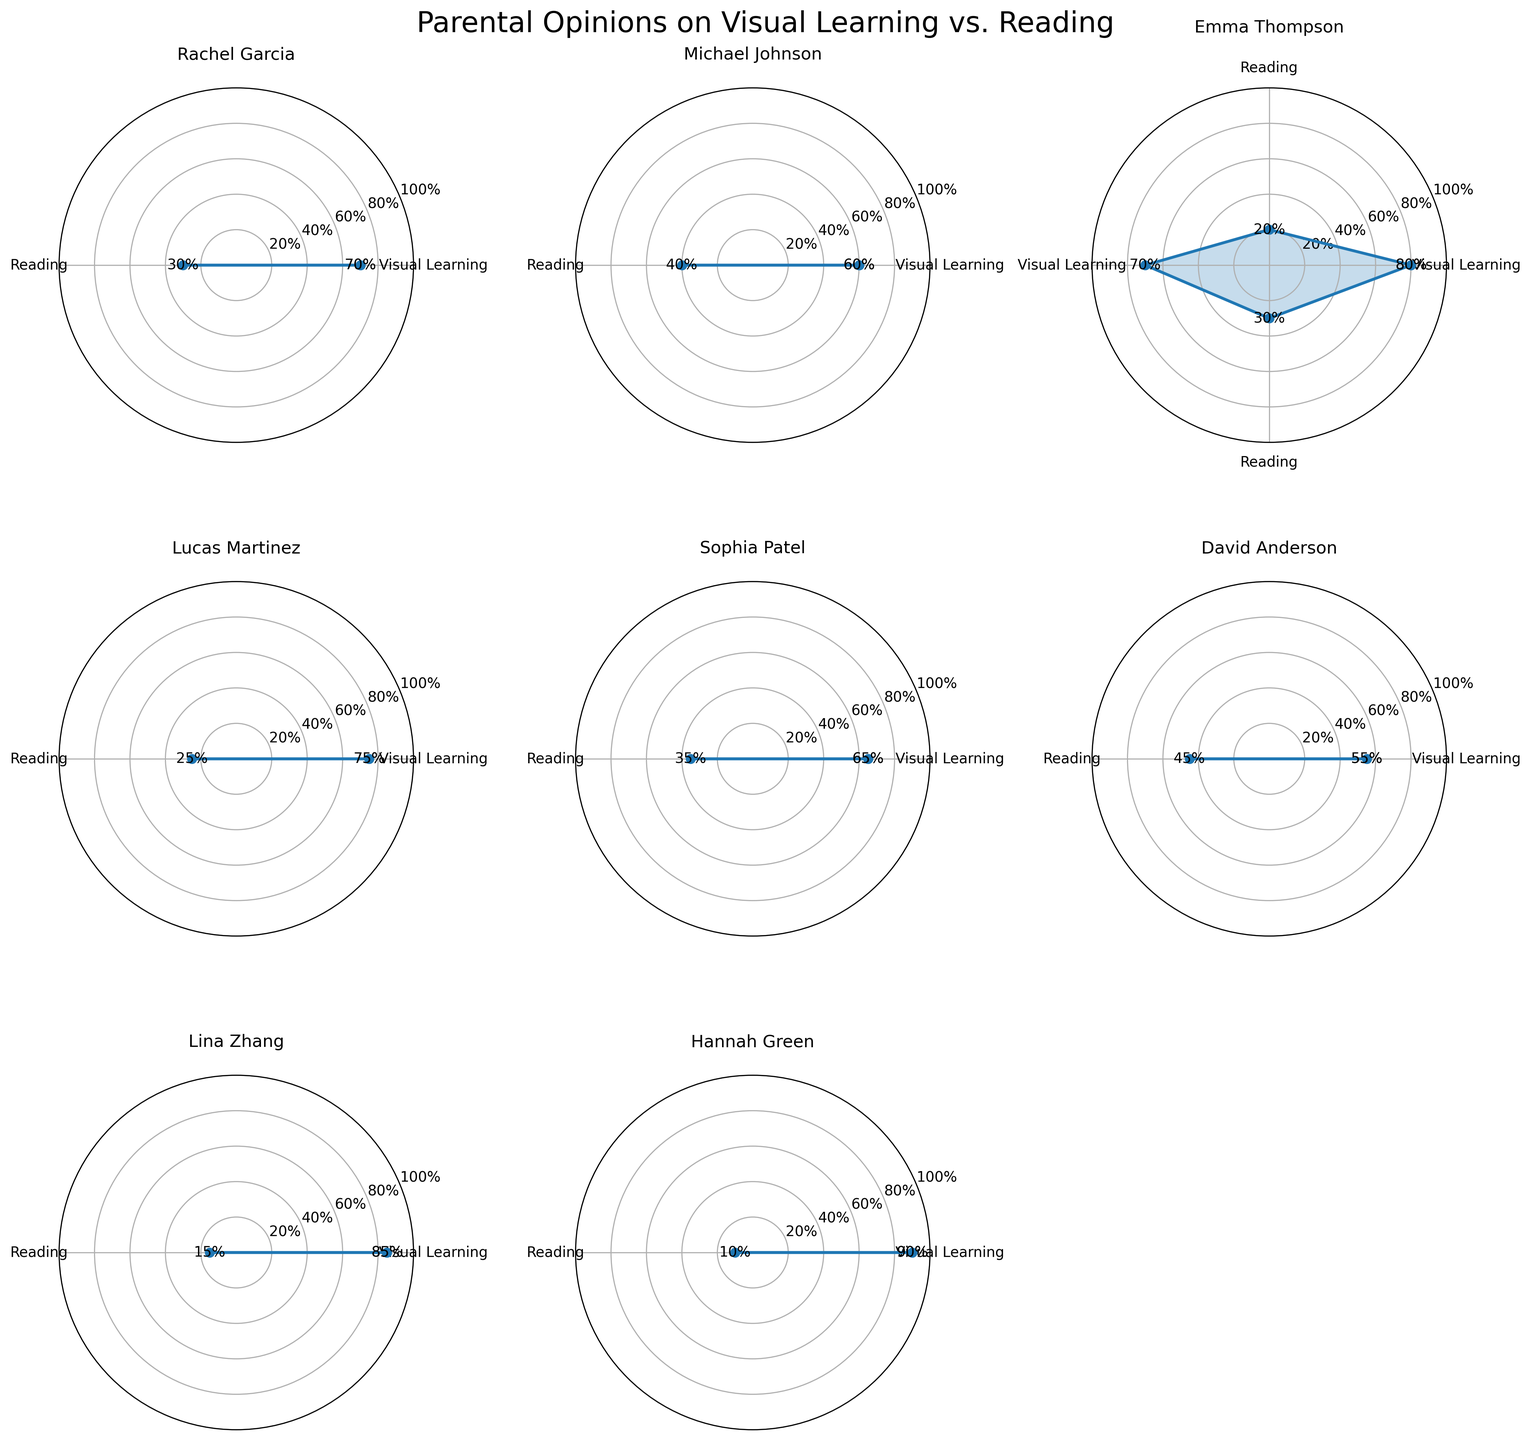What is the title of the figure? The title of the figure is usually placed at the top center and gives an overview of what the figure represents. In this case, the title reads "Parental Opinions on Visual Learning vs. Reading".
Answer: Parental Opinions on Visual Learning vs. Reading Which parent indicated the highest percentage in favor of visual learning? Look for the subplot where the percentage for "Visual Learning" is the highest. Hannah Green's subplot shows a 90% value for visual learning, which is the highest.
Answer: Hannah Green How many subplots in total are present in the figure? The total number of subplots is equivalent to the number of unique parents mentioned in the data. Count the subplots present in a 3x3 grid layout (maximum 9). Some cells might be empty, so check the number of actual subplots.
Answer: 8 Which parent has the most balanced opinion between visual learning and reading? To find the most balanced opinion, look for the subplot where the percentages for "Visual Learning" and "Reading" are the closest. For David Anderson, the values are 55% and 45%, which are the closest among all parents.
Answer: David Anderson Comparing Emma Thompson's two subplots, what is the difference in percentage for visual learning between them? Emma Thompson has two subplots. For visual learning, the values are 80% and 70%. The difference is 80% - 70% = 10%.
Answer: 10% Which parental opinion pairing shows the greatest disparity in favor of reading? To find the greatest disparity in favor of reading, identify the parent with the lowest percentage for visual learning. Lina Zhang has 85% for visual learning, implying 15% for reading, which is the smallest value for reading.
Answer: Lina Zhang What is the average percentage of parents who prefer visual learning over reading? Calculate the average percentage for visual learning by summing all the visual learning percentages and dividing by the number of parents (70 + 60 + 80 + 75 + 65 + 55 + 70 + 85 + 90) / 8 = 650 / 8 = 72.22.
Answer: 72.22% In Lucas Martinez's subplot, how does the percentage for visual learning compare to Sophia Patel's? Compare the values shown for visual learning in the subplots of Lucas Martinez (75%) and Sophia Patel (65%). Lucas Martinez has a 10% higher value.
Answer: Lucas Martinez's visual learning percentage is higher What is the total number of parents who support visual learning more than reading? Count the number of subplots where the percentage for visual learning is higher than reading. In this case, all 8 parents have higher percentages for visual learning.
Answer: 8 